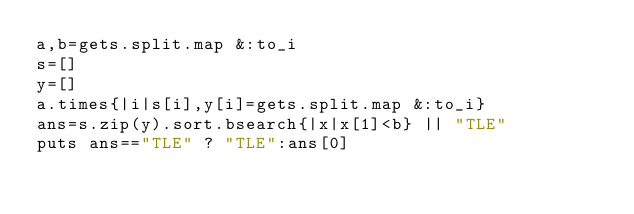Convert code to text. <code><loc_0><loc_0><loc_500><loc_500><_Ruby_>a,b=gets.split.map &:to_i
s=[]
y=[]
a.times{|i|s[i],y[i]=gets.split.map &:to_i}
ans=s.zip(y).sort.bsearch{|x|x[1]<b} || "TLE"
puts ans=="TLE" ? "TLE":ans[0]
</code> 